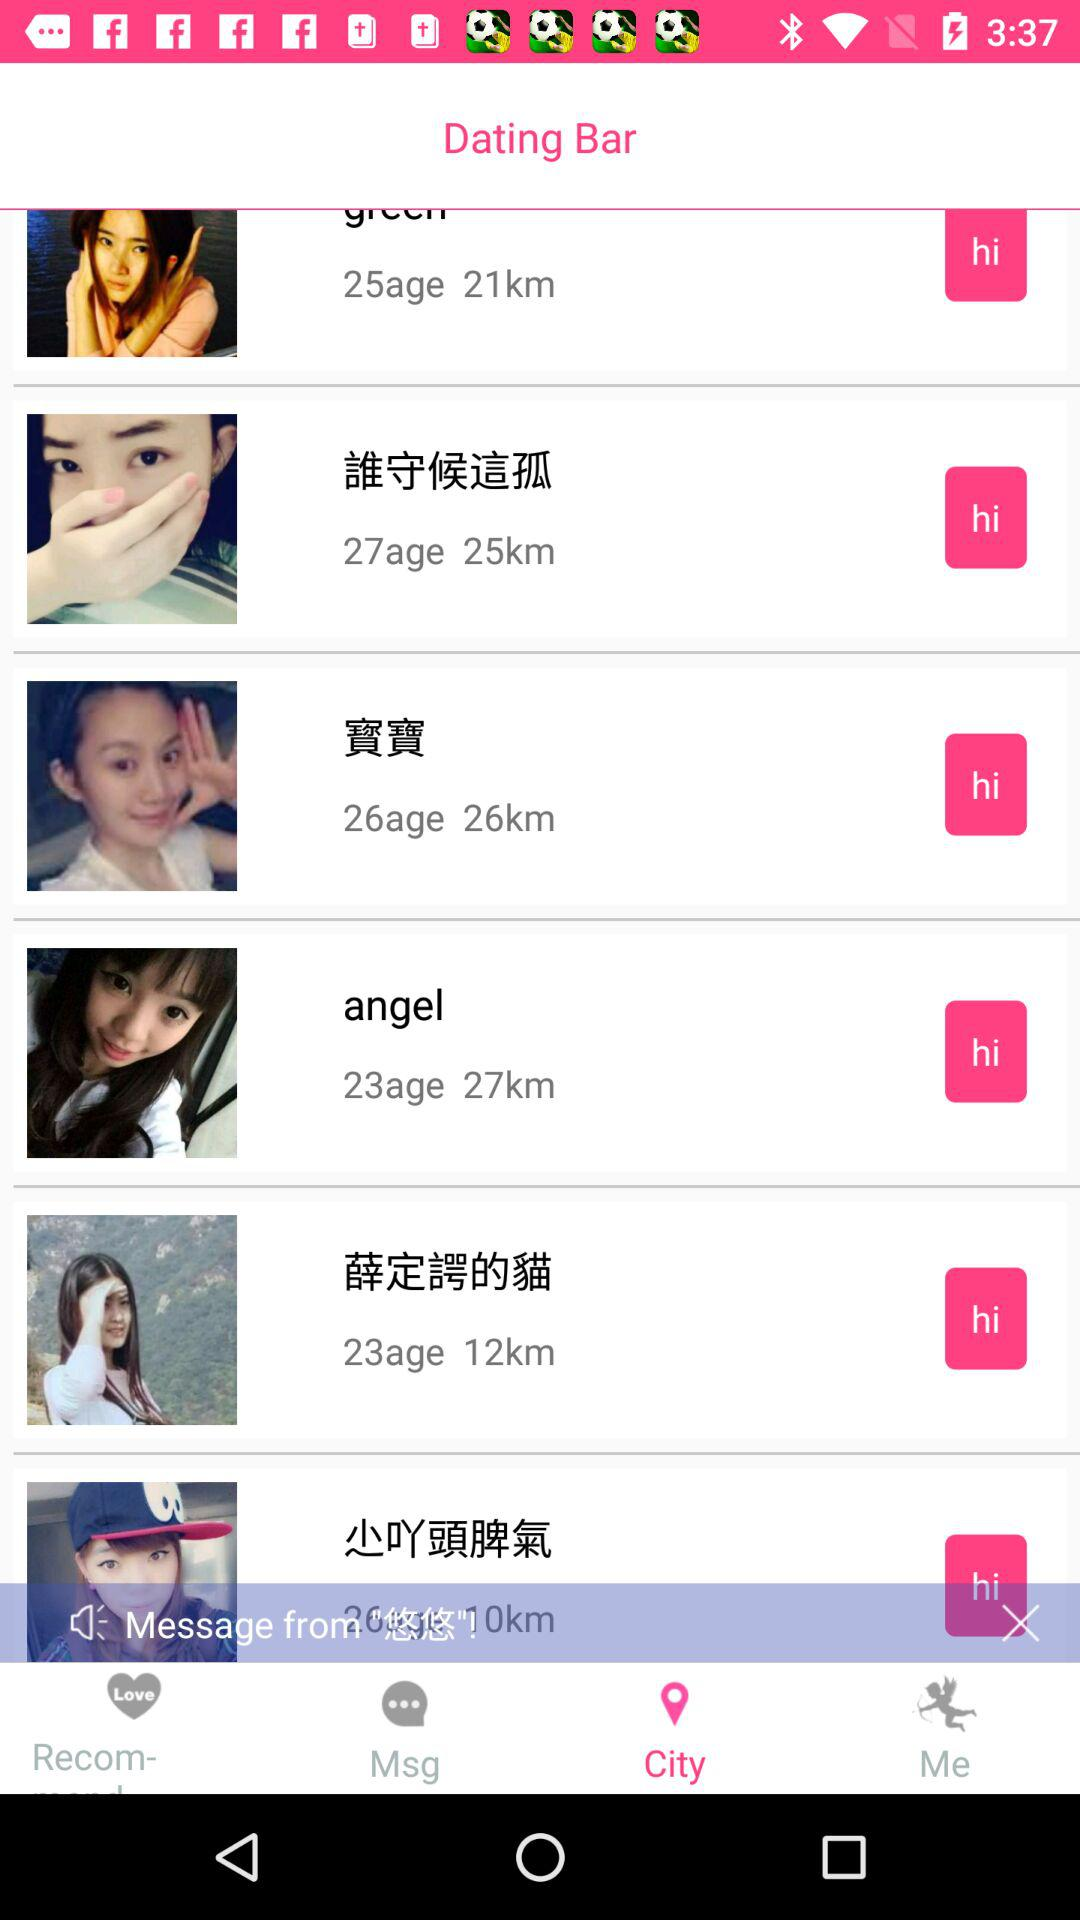What is the name of the application? The name of the application is "Dating Bar". 